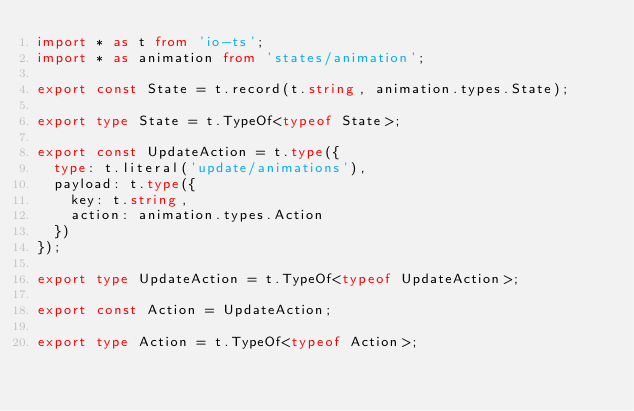<code> <loc_0><loc_0><loc_500><loc_500><_TypeScript_>import * as t from 'io-ts';
import * as animation from 'states/animation';

export const State = t.record(t.string, animation.types.State);

export type State = t.TypeOf<typeof State>;

export const UpdateAction = t.type({
  type: t.literal('update/animations'),
  payload: t.type({
    key: t.string,
    action: animation.types.Action
  })
});

export type UpdateAction = t.TypeOf<typeof UpdateAction>;

export const Action = UpdateAction;

export type Action = t.TypeOf<typeof Action>;
</code> 